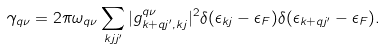Convert formula to latex. <formula><loc_0><loc_0><loc_500><loc_500>\gamma _ { q \nu } = 2 \pi \omega _ { q \nu } \sum _ { k j j ^ { \prime } } | g _ { k + q j ^ { \prime } , k j } ^ { q \nu } | ^ { 2 } \delta ( \epsilon _ { k j } - \epsilon _ { F } ) \delta ( \epsilon _ { k + q j ^ { \prime } } - \epsilon _ { F } ) .</formula> 